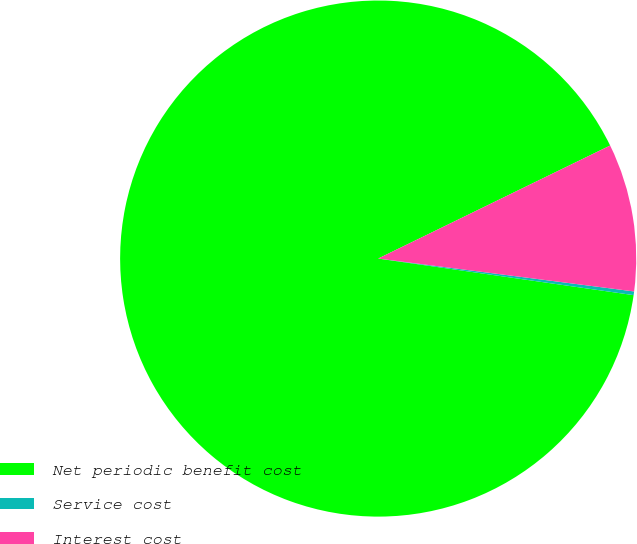Convert chart to OTSL. <chart><loc_0><loc_0><loc_500><loc_500><pie_chart><fcel>Net periodic benefit cost<fcel>Service cost<fcel>Interest cost<nl><fcel>90.52%<fcel>0.23%<fcel>9.25%<nl></chart> 